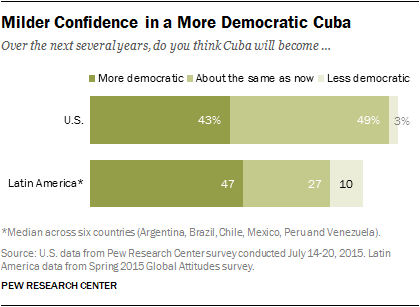Mention a couple of crucial points in this snapshot. The sum of all the three attitudes in Latin America is 84. According to a recent survey, 43% of Americans believe that Cuba will become more democratic in the future. 